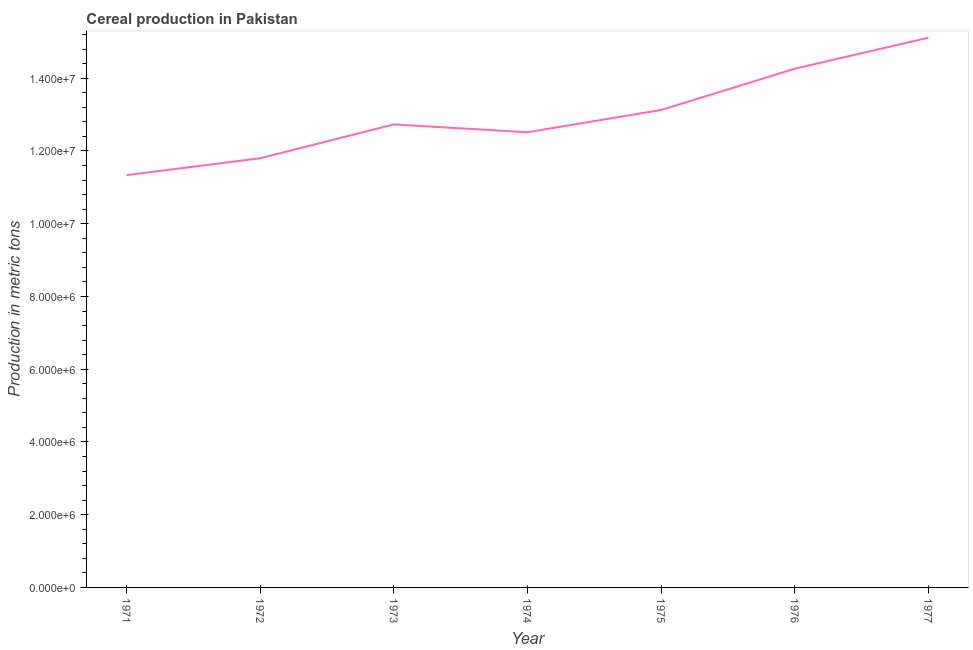What is the cereal production in 1977?
Keep it short and to the point. 1.51e+07. Across all years, what is the maximum cereal production?
Give a very brief answer. 1.51e+07. Across all years, what is the minimum cereal production?
Ensure brevity in your answer.  1.13e+07. What is the sum of the cereal production?
Keep it short and to the point. 9.09e+07. What is the difference between the cereal production in 1972 and 1974?
Your response must be concise. -7.15e+05. What is the average cereal production per year?
Provide a succinct answer. 1.30e+07. What is the median cereal production?
Your response must be concise. 1.27e+07. In how many years, is the cereal production greater than 2800000 metric tons?
Keep it short and to the point. 7. What is the ratio of the cereal production in 1971 to that in 1973?
Offer a very short reply. 0.89. Is the difference between the cereal production in 1971 and 1976 greater than the difference between any two years?
Make the answer very short. No. What is the difference between the highest and the second highest cereal production?
Offer a very short reply. 8.52e+05. Is the sum of the cereal production in 1971 and 1977 greater than the maximum cereal production across all years?
Your answer should be compact. Yes. What is the difference between the highest and the lowest cereal production?
Give a very brief answer. 3.78e+06. In how many years, is the cereal production greater than the average cereal production taken over all years?
Offer a very short reply. 3. Does the cereal production monotonically increase over the years?
Keep it short and to the point. No. How many lines are there?
Provide a short and direct response. 1. How many years are there in the graph?
Your answer should be compact. 7. Does the graph contain grids?
Provide a succinct answer. No. What is the title of the graph?
Provide a succinct answer. Cereal production in Pakistan. What is the label or title of the X-axis?
Provide a short and direct response. Year. What is the label or title of the Y-axis?
Ensure brevity in your answer.  Production in metric tons. What is the Production in metric tons in 1971?
Offer a very short reply. 1.13e+07. What is the Production in metric tons of 1972?
Keep it short and to the point. 1.18e+07. What is the Production in metric tons of 1973?
Offer a very short reply. 1.27e+07. What is the Production in metric tons in 1974?
Ensure brevity in your answer.  1.25e+07. What is the Production in metric tons in 1975?
Your answer should be very brief. 1.31e+07. What is the Production in metric tons of 1976?
Your answer should be very brief. 1.43e+07. What is the Production in metric tons of 1977?
Keep it short and to the point. 1.51e+07. What is the difference between the Production in metric tons in 1971 and 1972?
Offer a very short reply. -4.64e+05. What is the difference between the Production in metric tons in 1971 and 1973?
Offer a terse response. -1.39e+06. What is the difference between the Production in metric tons in 1971 and 1974?
Provide a short and direct response. -1.18e+06. What is the difference between the Production in metric tons in 1971 and 1975?
Your answer should be compact. -1.79e+06. What is the difference between the Production in metric tons in 1971 and 1976?
Your response must be concise. -2.93e+06. What is the difference between the Production in metric tons in 1971 and 1977?
Offer a very short reply. -3.78e+06. What is the difference between the Production in metric tons in 1972 and 1973?
Offer a very short reply. -9.30e+05. What is the difference between the Production in metric tons in 1972 and 1974?
Provide a succinct answer. -7.15e+05. What is the difference between the Production in metric tons in 1972 and 1975?
Your answer should be very brief. -1.33e+06. What is the difference between the Production in metric tons in 1972 and 1976?
Ensure brevity in your answer.  -2.46e+06. What is the difference between the Production in metric tons in 1972 and 1977?
Keep it short and to the point. -3.31e+06. What is the difference between the Production in metric tons in 1973 and 1974?
Make the answer very short. 2.15e+05. What is the difference between the Production in metric tons in 1973 and 1975?
Give a very brief answer. -3.97e+05. What is the difference between the Production in metric tons in 1973 and 1976?
Make the answer very short. -1.53e+06. What is the difference between the Production in metric tons in 1973 and 1977?
Your answer should be very brief. -2.38e+06. What is the difference between the Production in metric tons in 1974 and 1975?
Offer a terse response. -6.12e+05. What is the difference between the Production in metric tons in 1974 and 1976?
Your response must be concise. -1.75e+06. What is the difference between the Production in metric tons in 1974 and 1977?
Give a very brief answer. -2.60e+06. What is the difference between the Production in metric tons in 1975 and 1976?
Make the answer very short. -1.13e+06. What is the difference between the Production in metric tons in 1975 and 1977?
Keep it short and to the point. -1.99e+06. What is the difference between the Production in metric tons in 1976 and 1977?
Ensure brevity in your answer.  -8.52e+05. What is the ratio of the Production in metric tons in 1971 to that in 1972?
Your answer should be very brief. 0.96. What is the ratio of the Production in metric tons in 1971 to that in 1973?
Your response must be concise. 0.89. What is the ratio of the Production in metric tons in 1971 to that in 1974?
Ensure brevity in your answer.  0.91. What is the ratio of the Production in metric tons in 1971 to that in 1975?
Your answer should be compact. 0.86. What is the ratio of the Production in metric tons in 1971 to that in 1976?
Ensure brevity in your answer.  0.8. What is the ratio of the Production in metric tons in 1971 to that in 1977?
Ensure brevity in your answer.  0.75. What is the ratio of the Production in metric tons in 1972 to that in 1973?
Make the answer very short. 0.93. What is the ratio of the Production in metric tons in 1972 to that in 1974?
Your response must be concise. 0.94. What is the ratio of the Production in metric tons in 1972 to that in 1975?
Ensure brevity in your answer.  0.9. What is the ratio of the Production in metric tons in 1972 to that in 1976?
Your answer should be compact. 0.83. What is the ratio of the Production in metric tons in 1972 to that in 1977?
Keep it short and to the point. 0.78. What is the ratio of the Production in metric tons in 1973 to that in 1976?
Your answer should be very brief. 0.89. What is the ratio of the Production in metric tons in 1973 to that in 1977?
Ensure brevity in your answer.  0.84. What is the ratio of the Production in metric tons in 1974 to that in 1975?
Your answer should be compact. 0.95. What is the ratio of the Production in metric tons in 1974 to that in 1976?
Your response must be concise. 0.88. What is the ratio of the Production in metric tons in 1974 to that in 1977?
Provide a succinct answer. 0.83. What is the ratio of the Production in metric tons in 1975 to that in 1976?
Make the answer very short. 0.92. What is the ratio of the Production in metric tons in 1975 to that in 1977?
Provide a succinct answer. 0.87. What is the ratio of the Production in metric tons in 1976 to that in 1977?
Your response must be concise. 0.94. 